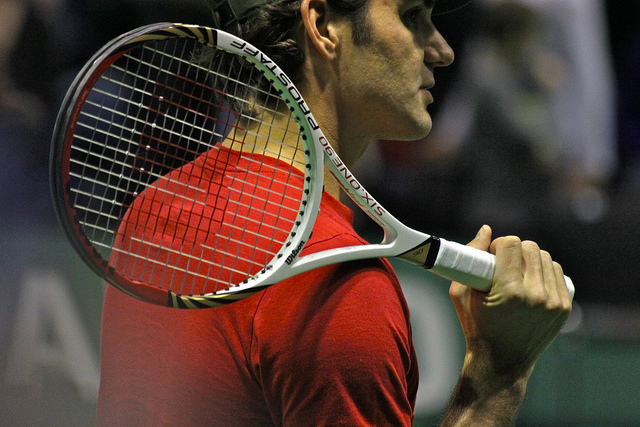<image>Is the man a tennis legend? I don't know if the man is a tennis legend. Is the man a tennis legend? I don't know if the man is a tennis legend. It can be both yes or no. 